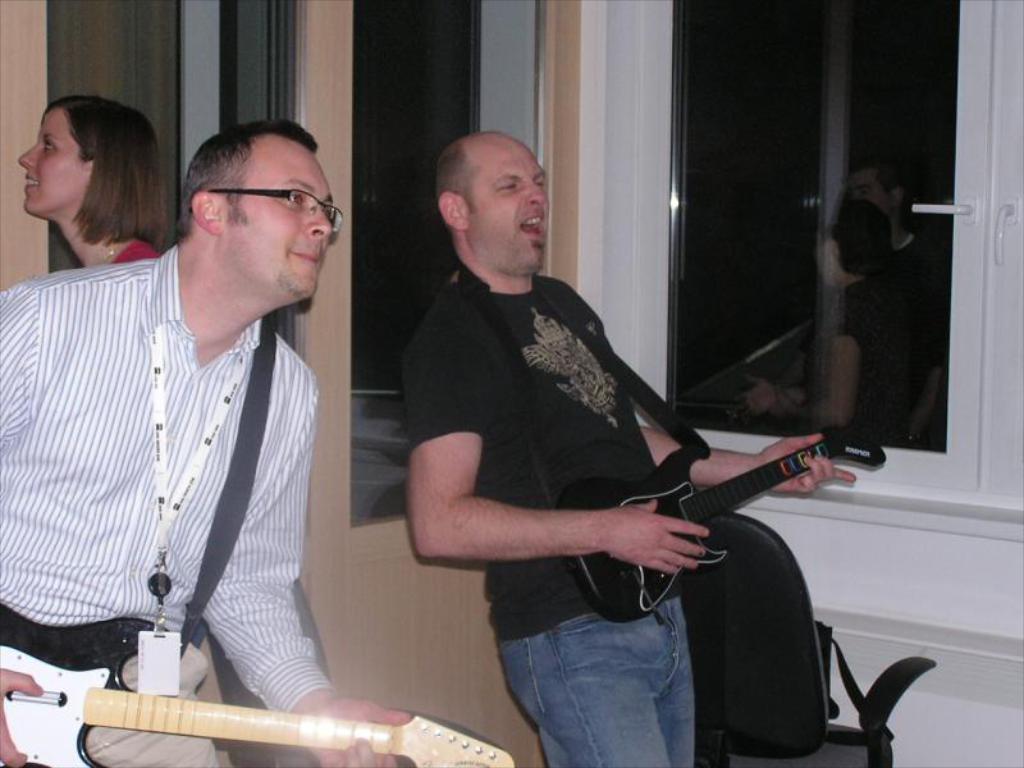Describe this image in one or two sentences. These two persons are playing guitar. The man in black t-shirt is singing and playing guitar. In this window there is a reflection of persons. Backside of this person another woman is standing. This man wore id card and spectacles. Beside this man there is a chair. 